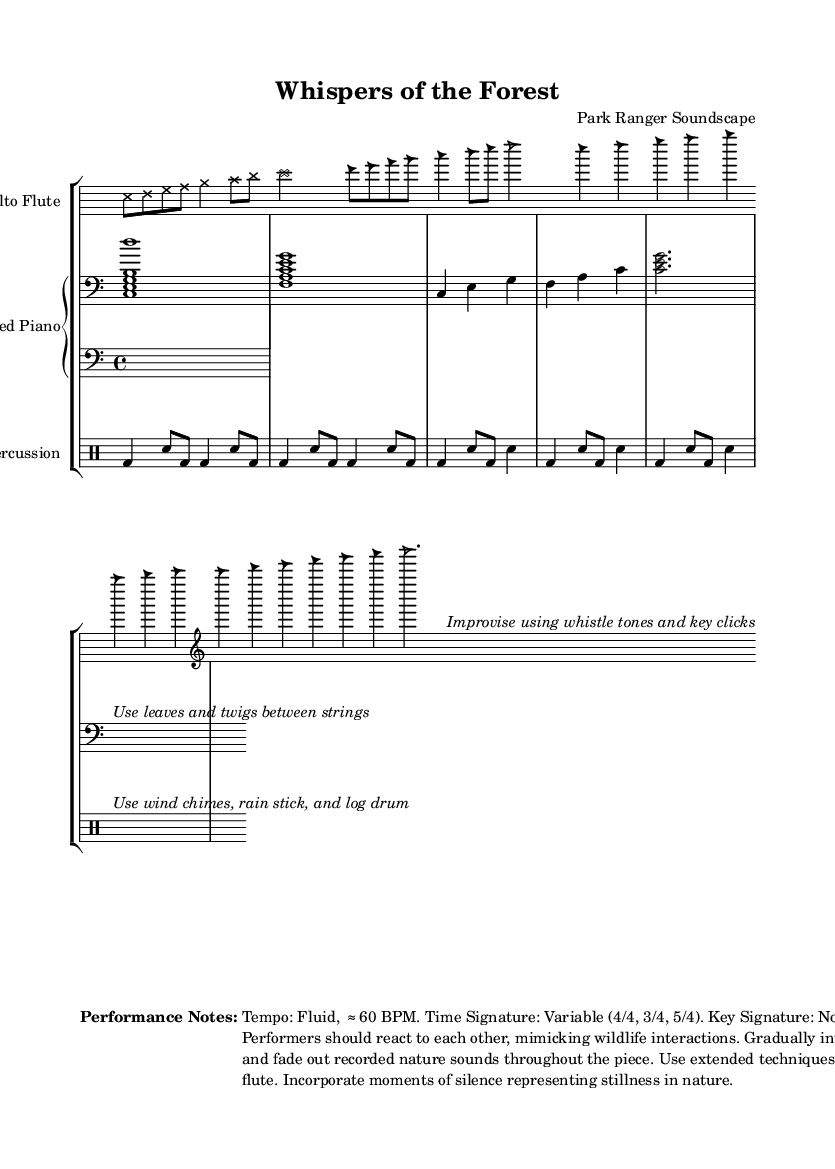What is the time signature of the alto flute section? The alto flute section has a variable time signature that includes both 4/4 and 3/4. The score indicates the use of 4/4 in the graphic notation and later switches to 3/4 in the traditional notation.
Answer: 4/4 and 3/4 What notation styles are used in the piece? The piece utilizes multiple notation styles, including graphic notation (cross and triangle note heads), time-space notation (line positions), and traditional notation (standard pitch notation). This variety represents the unique elements of avant-garde compositions.
Answer: Graphic notation, time-space notation, traditional notation How many measures of music are in the percussion section? The percussion section includes various measures; counting the notated sections yields a total of five measures: two in 4/4 and three in 3/4. The distinct time signatures contribute to the overall dynamic rhythm.
Answer: Five measures What instruments are featured in this composition? The composition features three instruments: alto flute, prepared piano, and percussion. Each brings its distinctive sound, contributing to the experimental nature of the piece.
Answer: Alto flute, prepared piano, percussion Which extended techniques are suggested for the alto flute? The performance notes for the alto flute suggest improvisation with whistle tones and key clicks. These techniques encourage the player to mimic wildlife interactions, enriching the performance's ecological theme.
Answer: Whistle tones and key clicks 